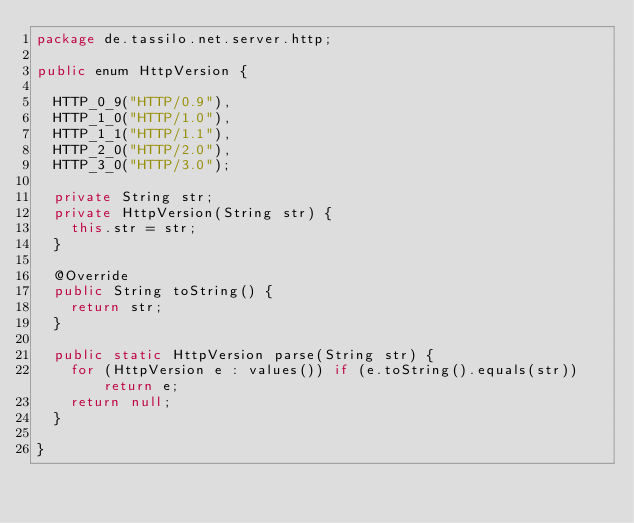Convert code to text. <code><loc_0><loc_0><loc_500><loc_500><_Java_>package de.tassilo.net.server.http;

public enum HttpVersion {

	HTTP_0_9("HTTP/0.9"),
	HTTP_1_0("HTTP/1.0"),
	HTTP_1_1("HTTP/1.1"),
	HTTP_2_0("HTTP/2.0"),
	HTTP_3_0("HTTP/3.0");

	private String str;
	private HttpVersion(String str) {
		this.str = str;
	}

	@Override
	public String toString() {
		return str;
	}

	public static HttpVersion parse(String str) {
		for (HttpVersion e : values()) if (e.toString().equals(str)) return e;
		return null;
	}

}
</code> 